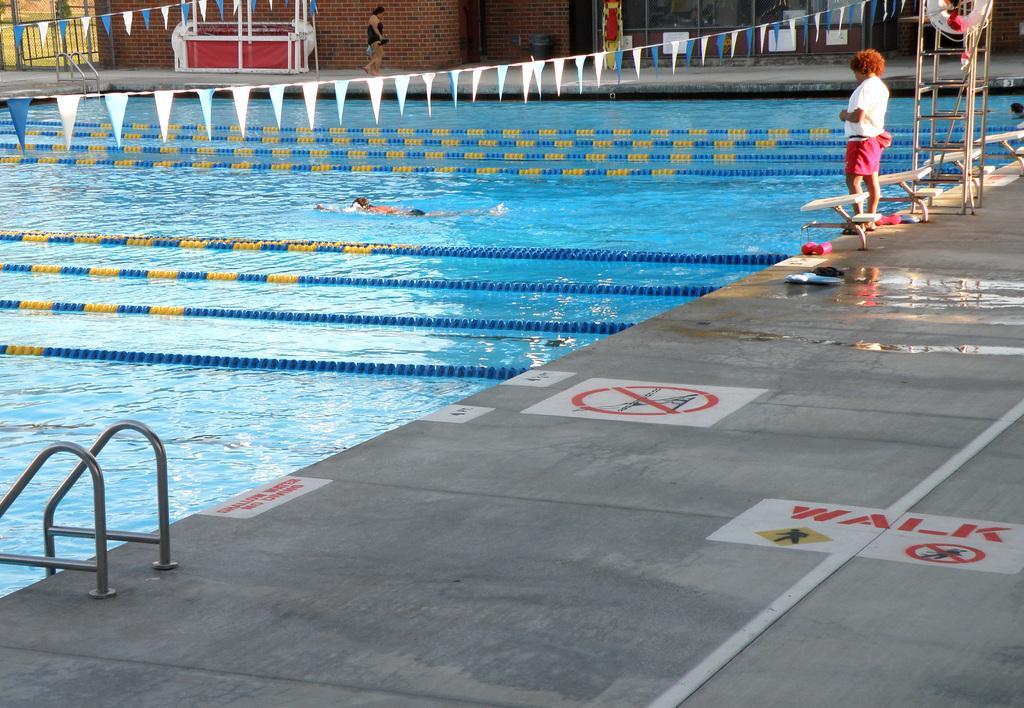Please provide a concise description of this image. In this picture there is a swimming pool in the image and there is a lady and a ladder in the image, there is another lady and a desk at the top side of the image. 